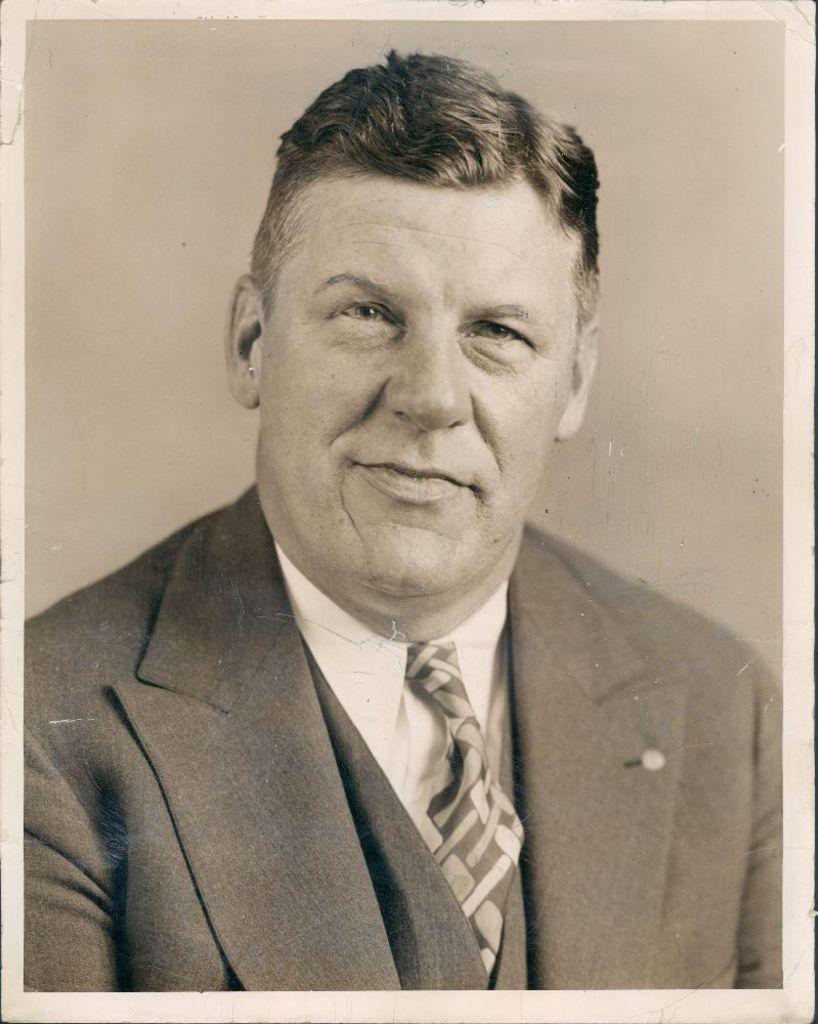What is the main subject of the image? The main subject of the image is a photograph of a man. What is the man wearing in the image? The man is wearing a suit in the image. How many birds are perched on the man's shoulder in the image? There are no birds present in the image. What is the man's limit for taking on new tasks in the image? The image does not provide information about the man's limits or abilities. 